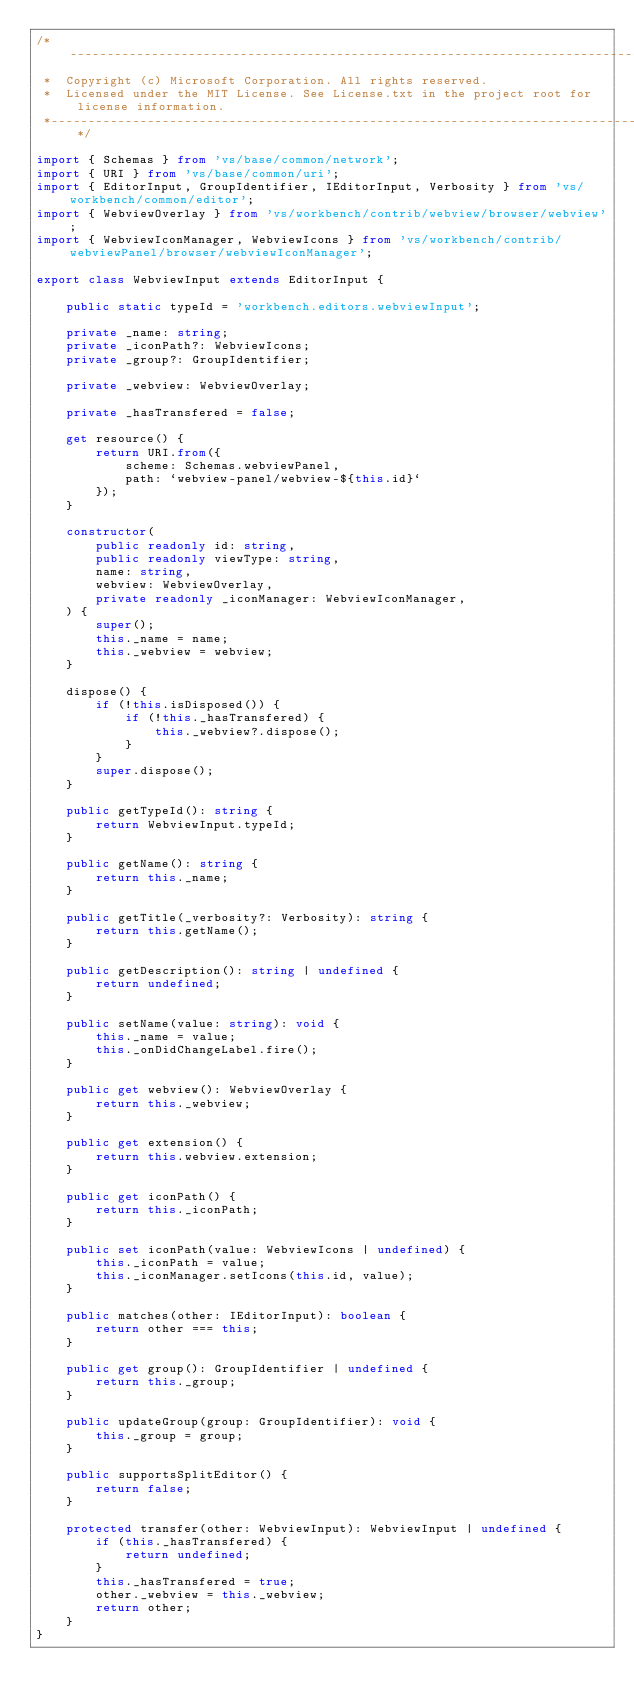<code> <loc_0><loc_0><loc_500><loc_500><_TypeScript_>/*---------------------------------------------------------------------------------------------
 *  Copyright (c) Microsoft Corporation. All rights reserved.
 *  Licensed under the MIT License. See License.txt in the project root for license information.
 *--------------------------------------------------------------------------------------------*/

import { Schemas } from 'vs/base/common/network';
import { URI } from 'vs/base/common/uri';
import { EditorInput, GroupIdentifier, IEditorInput, Verbosity } from 'vs/workbench/common/editor';
import { WebviewOverlay } from 'vs/workbench/contrib/webview/browser/webview';
import { WebviewIconManager, WebviewIcons } from 'vs/workbench/contrib/webviewPanel/browser/webviewIconManager';

export class WebviewInput extends EditorInput {

	public static typeId = 'workbench.editors.webviewInput';

	private _name: string;
	private _iconPath?: WebviewIcons;
	private _group?: GroupIdentifier;

	private _webview: WebviewOverlay;

	private _hasTransfered = false;

	get resource() {
		return URI.from({
			scheme: Schemas.webviewPanel,
			path: `webview-panel/webview-${this.id}`
		});
	}

	constructor(
		public readonly id: string,
		public readonly viewType: string,
		name: string,
		webview: WebviewOverlay,
		private readonly _iconManager: WebviewIconManager,
	) {
		super();
		this._name = name;
		this._webview = webview;
	}

	dispose() {
		if (!this.isDisposed()) {
			if (!this._hasTransfered) {
				this._webview?.dispose();
			}
		}
		super.dispose();
	}

	public getTypeId(): string {
		return WebviewInput.typeId;
	}

	public getName(): string {
		return this._name;
	}

	public getTitle(_verbosity?: Verbosity): string {
		return this.getName();
	}

	public getDescription(): string | undefined {
		return undefined;
	}

	public setName(value: string): void {
		this._name = value;
		this._onDidChangeLabel.fire();
	}

	public get webview(): WebviewOverlay {
		return this._webview;
	}

	public get extension() {
		return this.webview.extension;
	}

	public get iconPath() {
		return this._iconPath;
	}

	public set iconPath(value: WebviewIcons | undefined) {
		this._iconPath = value;
		this._iconManager.setIcons(this.id, value);
	}

	public matches(other: IEditorInput): boolean {
		return other === this;
	}

	public get group(): GroupIdentifier | undefined {
		return this._group;
	}

	public updateGroup(group: GroupIdentifier): void {
		this._group = group;
	}

	public supportsSplitEditor() {
		return false;
	}

	protected transfer(other: WebviewInput): WebviewInput | undefined {
		if (this._hasTransfered) {
			return undefined;
		}
		this._hasTransfered = true;
		other._webview = this._webview;
		return other;
	}
}
</code> 